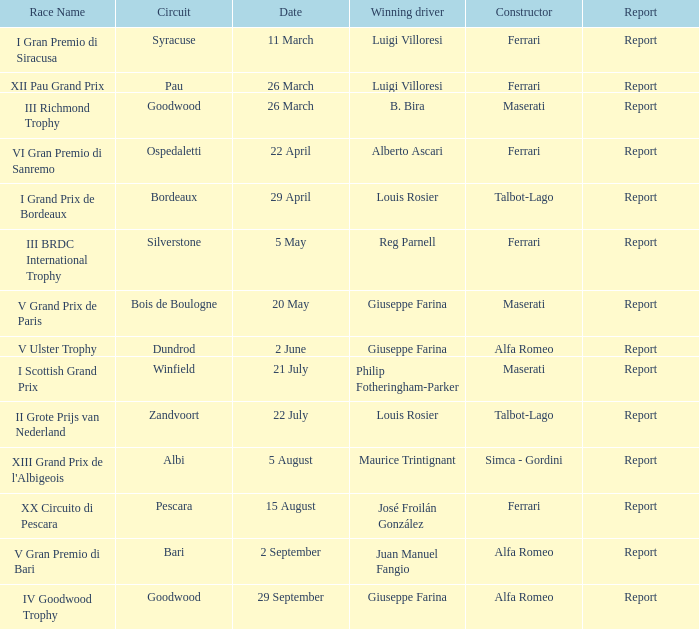Name the report for philip fotheringham-parker Report. 